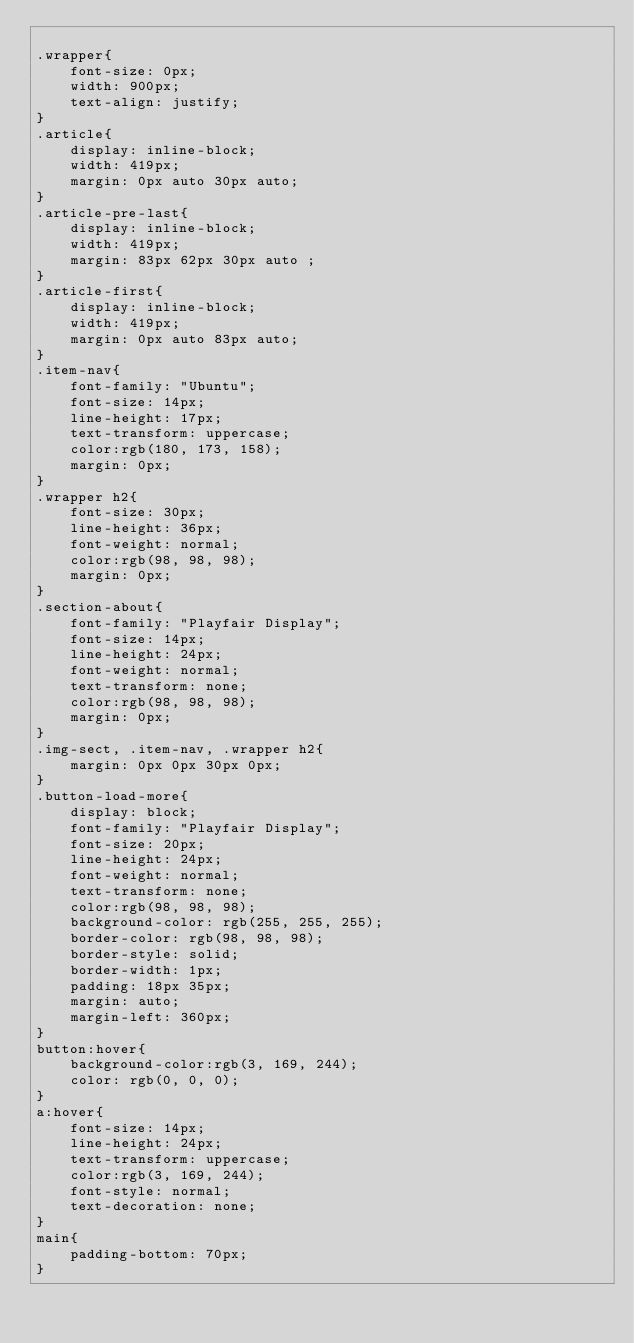Convert code to text. <code><loc_0><loc_0><loc_500><loc_500><_CSS_>    
.wrapper{
    font-size: 0px;
    width: 900px;
    text-align: justify;
}
.article{
    display: inline-block;
    width: 419px;
    margin: 0px auto 30px auto;
}
.article-pre-last{
    display: inline-block;
    width: 419px;
    margin: 83px 62px 30px auto ;
}
.article-first{
    display: inline-block;
    width: 419px;
    margin: 0px auto 83px auto;
}
.item-nav{
    font-family: "Ubuntu";
    font-size: 14px;
    line-height: 17px;
    text-transform: uppercase;
    color:rgb(180, 173, 158);
    margin: 0px;
}
.wrapper h2{
    font-size: 30px;
    line-height: 36px;
    font-weight: normal;
    color:rgb(98, 98, 98);
    margin: 0px;
}
.section-about{
    font-family: "Playfair Display";
    font-size: 14px;
    line-height: 24px;
    font-weight: normal;
    text-transform: none;
    color:rgb(98, 98, 98);
    margin: 0px;
}
.img-sect, .item-nav, .wrapper h2{
    margin: 0px 0px 30px 0px;
}
.button-load-more{
    display: block;
    font-family: "Playfair Display";
    font-size: 20px;
    line-height: 24px;
    font-weight: normal;
    text-transform: none;
    color:rgb(98, 98, 98);
    background-color: rgb(255, 255, 255);
    border-color: rgb(98, 98, 98);
    border-style: solid;
    border-width: 1px;
    padding: 18px 35px;
    margin: auto;
    margin-left: 360px;
}
button:hover{
    background-color:rgb(3, 169, 244);
    color: rgb(0, 0, 0);
}
a:hover{
    font-size: 14px;
    line-height: 24px;
    text-transform: uppercase;
    color:rgb(3, 169, 244);
    font-style: normal;
    text-decoration: none;
}
main{
    padding-bottom: 70px;
}
</code> 